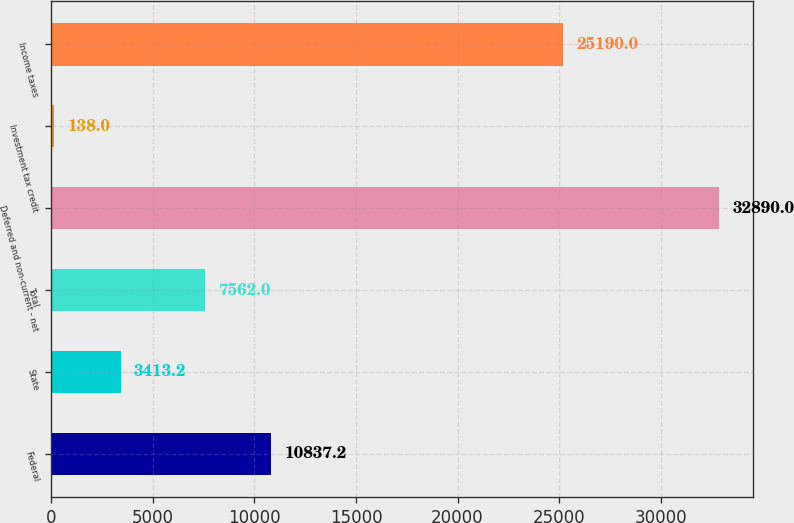Convert chart to OTSL. <chart><loc_0><loc_0><loc_500><loc_500><bar_chart><fcel>Federal<fcel>State<fcel>Total<fcel>Deferred and non-current - net<fcel>Investment tax credit<fcel>Income taxes<nl><fcel>10837.2<fcel>3413.2<fcel>7562<fcel>32890<fcel>138<fcel>25190<nl></chart> 